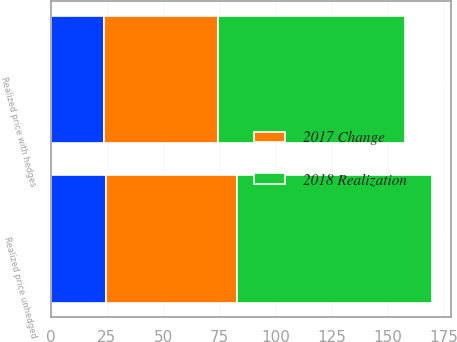Convert chart to OTSL. <chart><loc_0><loc_0><loc_500><loc_500><stacked_bar_chart><ecel><fcel>Realized price unhedged<fcel>Realized price with hedges<nl><fcel>nan<fcel>24.74<fcel>23.57<nl><fcel>2018 Realization<fcel>87<fcel>83<nl><fcel>2017 Change<fcel>58<fcel>51<nl></chart> 